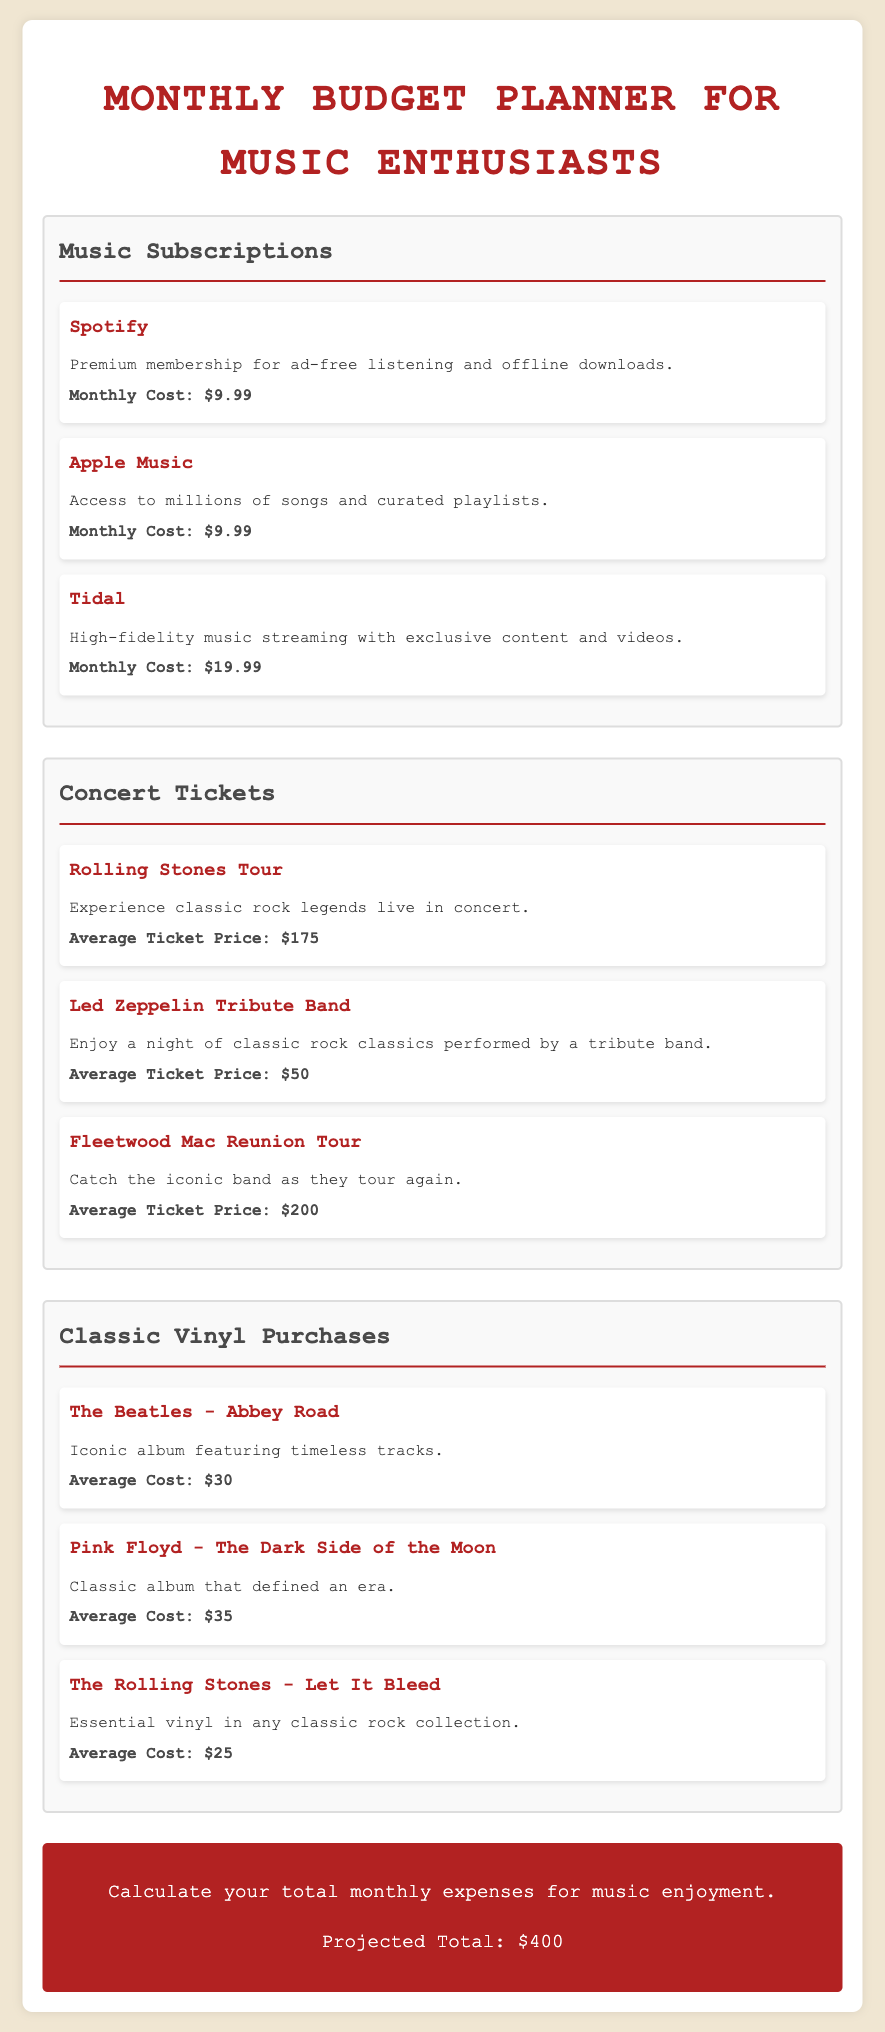What is the monthly cost of Apple Music? The document states that the monthly cost for Apple Music is $9.99.
Answer: $9.99 What is the average ticket price for the Fleetwood Mac Reunion Tour? The document lists the average ticket price for the Fleetwood Mac Reunion Tour as $200.
Answer: $200 Which classic album costs an average of $35? The document specifies that Pink Floyd - The Dark Side of the Moon costs an average of $35.
Answer: Pink Floyd - The Dark Side of the Moon How many music subscription options are listed? The document mentions three music subscription options: Spotify, Apple Music, and Tidal.
Answer: 3 What is the total projected monthly expense for music enjoyment? According to the document, the projected total for monthly expenses is $400.
Answer: $400 Which concert ticket is the most expensive? The document indicates that the average ticket price for the Rolling Stones Tour is the highest at $175.
Answer: Rolling Stones Tour What type of music does the document focus on? The document is designed for music enthusiasts, specifically classic rock enthusiasts.
Answer: Classic rock Which classic vinyl is considered essential in any classic rock collection? The document lists The Rolling Stones - Let It Bleed as an essential vinyl in any classic rock collection.
Answer: The Rolling Stones - Let It Bleed 